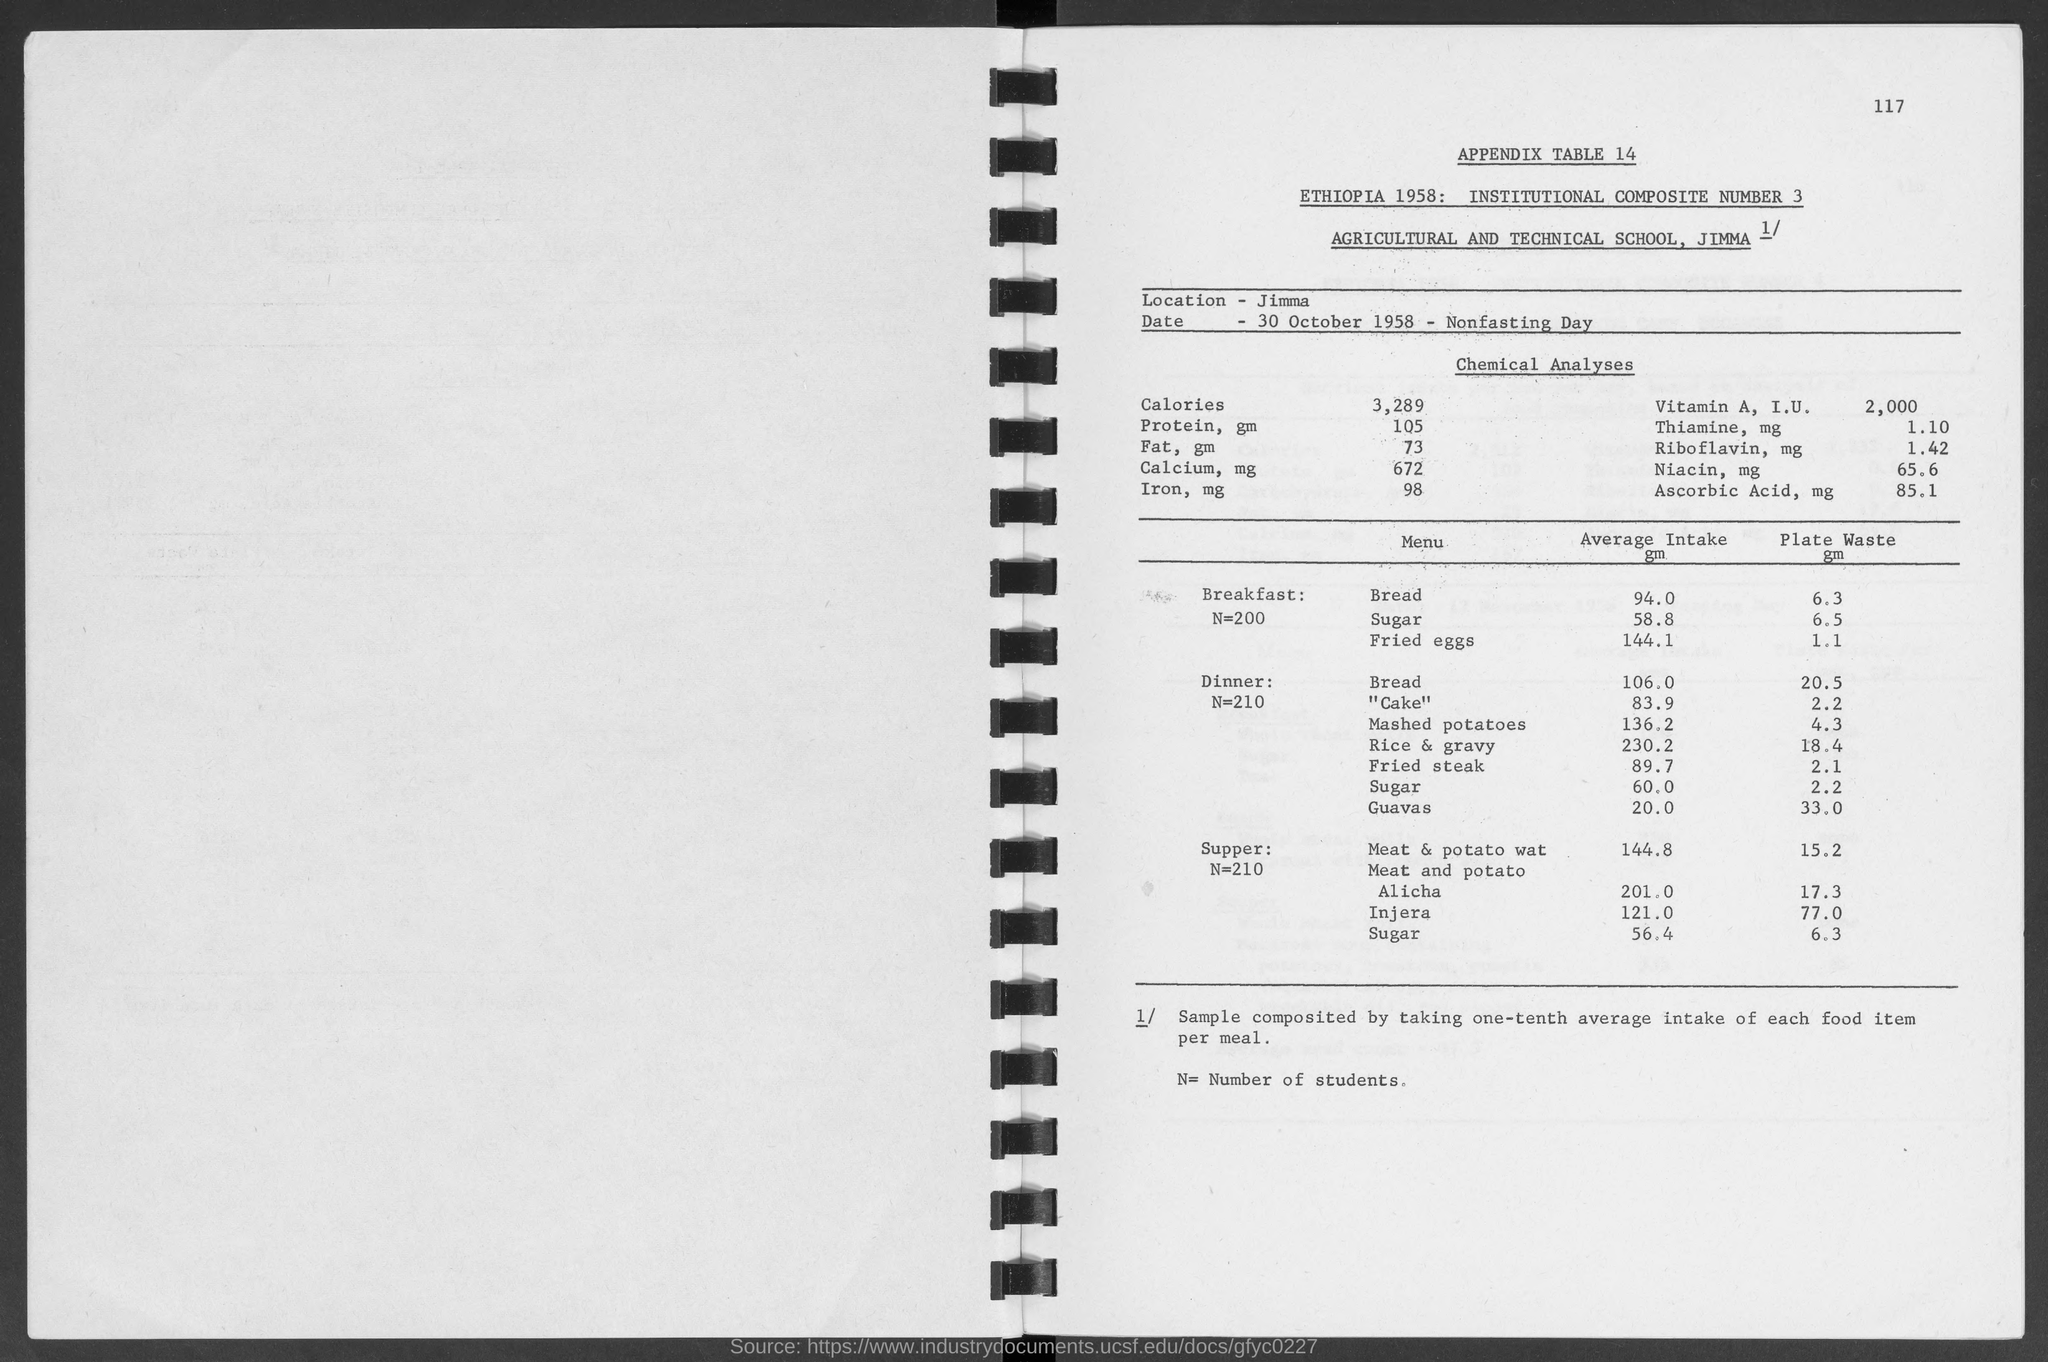What is the number at top-right corner of the page?
Offer a terse response. 117. What is the appendix table no.?
Make the answer very short. 14. What is the average intake of sugar in breakfast?
Offer a terse response. 58.8 gm. What is the average intake of bread  in breakfast?
Keep it short and to the point. 94.0 gm. What is the average intake of bread in dinner ?
Provide a succinct answer. 106.0. What is the average intake of sugar in dinner ?
Offer a terse response. 60.0 gm. What is the average intake of "cake" in dinner ?
Your response must be concise. 83.9. 